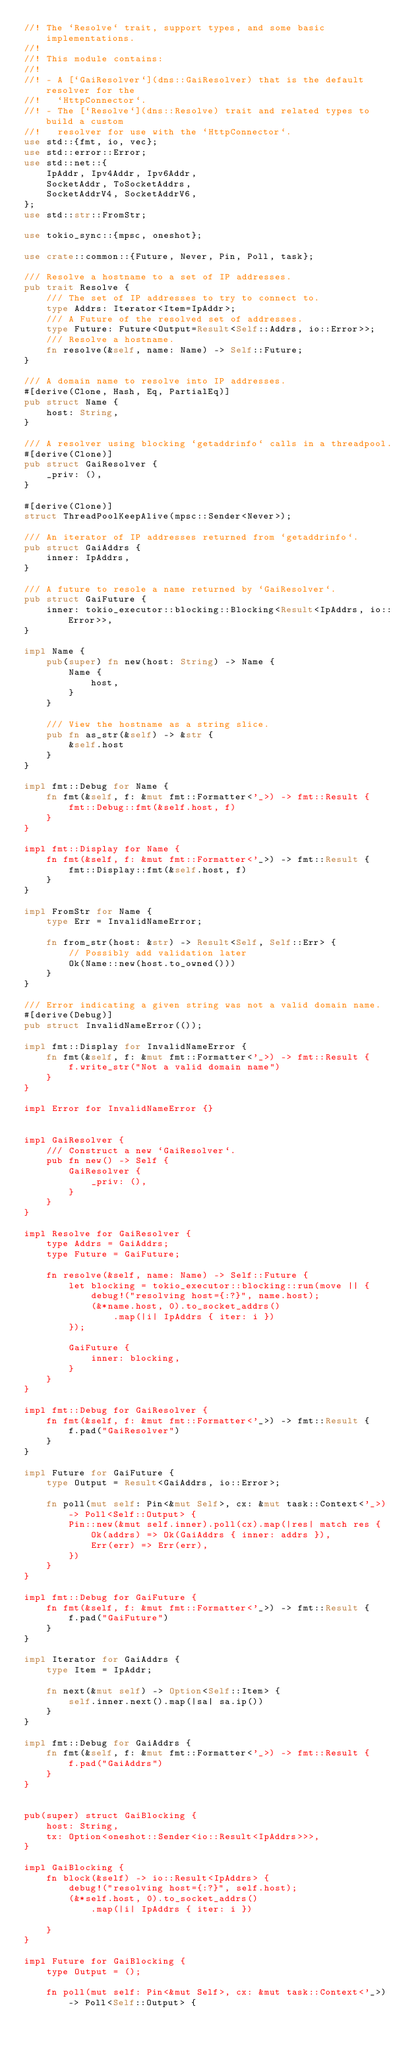Convert code to text. <code><loc_0><loc_0><loc_500><loc_500><_Rust_>//! The `Resolve` trait, support types, and some basic implementations.
//!
//! This module contains:
//!
//! - A [`GaiResolver`](dns::GaiResolver) that is the default resolver for the
//!   `HttpConnector`.
//! - The [`Resolve`](dns::Resolve) trait and related types to build a custom
//!   resolver for use with the `HttpConnector`.
use std::{fmt, io, vec};
use std::error::Error;
use std::net::{
    IpAddr, Ipv4Addr, Ipv6Addr,
    SocketAddr, ToSocketAddrs,
    SocketAddrV4, SocketAddrV6,
};
use std::str::FromStr;

use tokio_sync::{mpsc, oneshot};

use crate::common::{Future, Never, Pin, Poll, task};

/// Resolve a hostname to a set of IP addresses.
pub trait Resolve {
    /// The set of IP addresses to try to connect to.
    type Addrs: Iterator<Item=IpAddr>;
    /// A Future of the resolved set of addresses.
    type Future: Future<Output=Result<Self::Addrs, io::Error>>;
    /// Resolve a hostname.
    fn resolve(&self, name: Name) -> Self::Future;
}

/// A domain name to resolve into IP addresses.
#[derive(Clone, Hash, Eq, PartialEq)]
pub struct Name {
    host: String,
}

/// A resolver using blocking `getaddrinfo` calls in a threadpool.
#[derive(Clone)]
pub struct GaiResolver {
    _priv: (),
}

#[derive(Clone)]
struct ThreadPoolKeepAlive(mpsc::Sender<Never>);

/// An iterator of IP addresses returned from `getaddrinfo`.
pub struct GaiAddrs {
    inner: IpAddrs,
}

/// A future to resole a name returned by `GaiResolver`.
pub struct GaiFuture {
    inner: tokio_executor::blocking::Blocking<Result<IpAddrs, io::Error>>,
}

impl Name {
    pub(super) fn new(host: String) -> Name {
        Name {
            host,
        }
    }

    /// View the hostname as a string slice.
    pub fn as_str(&self) -> &str {
        &self.host
    }
}

impl fmt::Debug for Name {
    fn fmt(&self, f: &mut fmt::Formatter<'_>) -> fmt::Result {
        fmt::Debug::fmt(&self.host, f)
    }
}

impl fmt::Display for Name {
    fn fmt(&self, f: &mut fmt::Formatter<'_>) -> fmt::Result {
        fmt::Display::fmt(&self.host, f)
    }
}

impl FromStr for Name {
    type Err = InvalidNameError;

    fn from_str(host: &str) -> Result<Self, Self::Err> {
        // Possibly add validation later
        Ok(Name::new(host.to_owned()))
    }
}

/// Error indicating a given string was not a valid domain name.
#[derive(Debug)]
pub struct InvalidNameError(());

impl fmt::Display for InvalidNameError {
    fn fmt(&self, f: &mut fmt::Formatter<'_>) -> fmt::Result {
        f.write_str("Not a valid domain name")
    }
}

impl Error for InvalidNameError {}


impl GaiResolver {
    /// Construct a new `GaiResolver`.
    pub fn new() -> Self {
        GaiResolver {
            _priv: (),
        }
    }
}

impl Resolve for GaiResolver {
    type Addrs = GaiAddrs;
    type Future = GaiFuture;

    fn resolve(&self, name: Name) -> Self::Future {
        let blocking = tokio_executor::blocking::run(move || {
            debug!("resolving host={:?}", name.host);
            (&*name.host, 0).to_socket_addrs()
                .map(|i| IpAddrs { iter: i })
        });

        GaiFuture {
            inner: blocking,
        }
    }
}

impl fmt::Debug for GaiResolver {
    fn fmt(&self, f: &mut fmt::Formatter<'_>) -> fmt::Result {
        f.pad("GaiResolver")
    }
}

impl Future for GaiFuture {
    type Output = Result<GaiAddrs, io::Error>;

    fn poll(mut self: Pin<&mut Self>, cx: &mut task::Context<'_>) -> Poll<Self::Output> {
        Pin::new(&mut self.inner).poll(cx).map(|res| match res {
            Ok(addrs) => Ok(GaiAddrs { inner: addrs }),
            Err(err) => Err(err),
        })
    }
}

impl fmt::Debug for GaiFuture {
    fn fmt(&self, f: &mut fmt::Formatter<'_>) -> fmt::Result {
        f.pad("GaiFuture")
    }
}

impl Iterator for GaiAddrs {
    type Item = IpAddr;

    fn next(&mut self) -> Option<Self::Item> {
        self.inner.next().map(|sa| sa.ip())
    }
}

impl fmt::Debug for GaiAddrs {
    fn fmt(&self, f: &mut fmt::Formatter<'_>) -> fmt::Result {
        f.pad("GaiAddrs")
    }
}


pub(super) struct GaiBlocking {
    host: String,
    tx: Option<oneshot::Sender<io::Result<IpAddrs>>>,
}

impl GaiBlocking {
    fn block(&self) -> io::Result<IpAddrs> {
        debug!("resolving host={:?}", self.host);
        (&*self.host, 0).to_socket_addrs()
            .map(|i| IpAddrs { iter: i })

    }
}

impl Future for GaiBlocking {
    type Output = ();

    fn poll(mut self: Pin<&mut Self>, cx: &mut task::Context<'_>) -> Poll<Self::Output> {</code> 